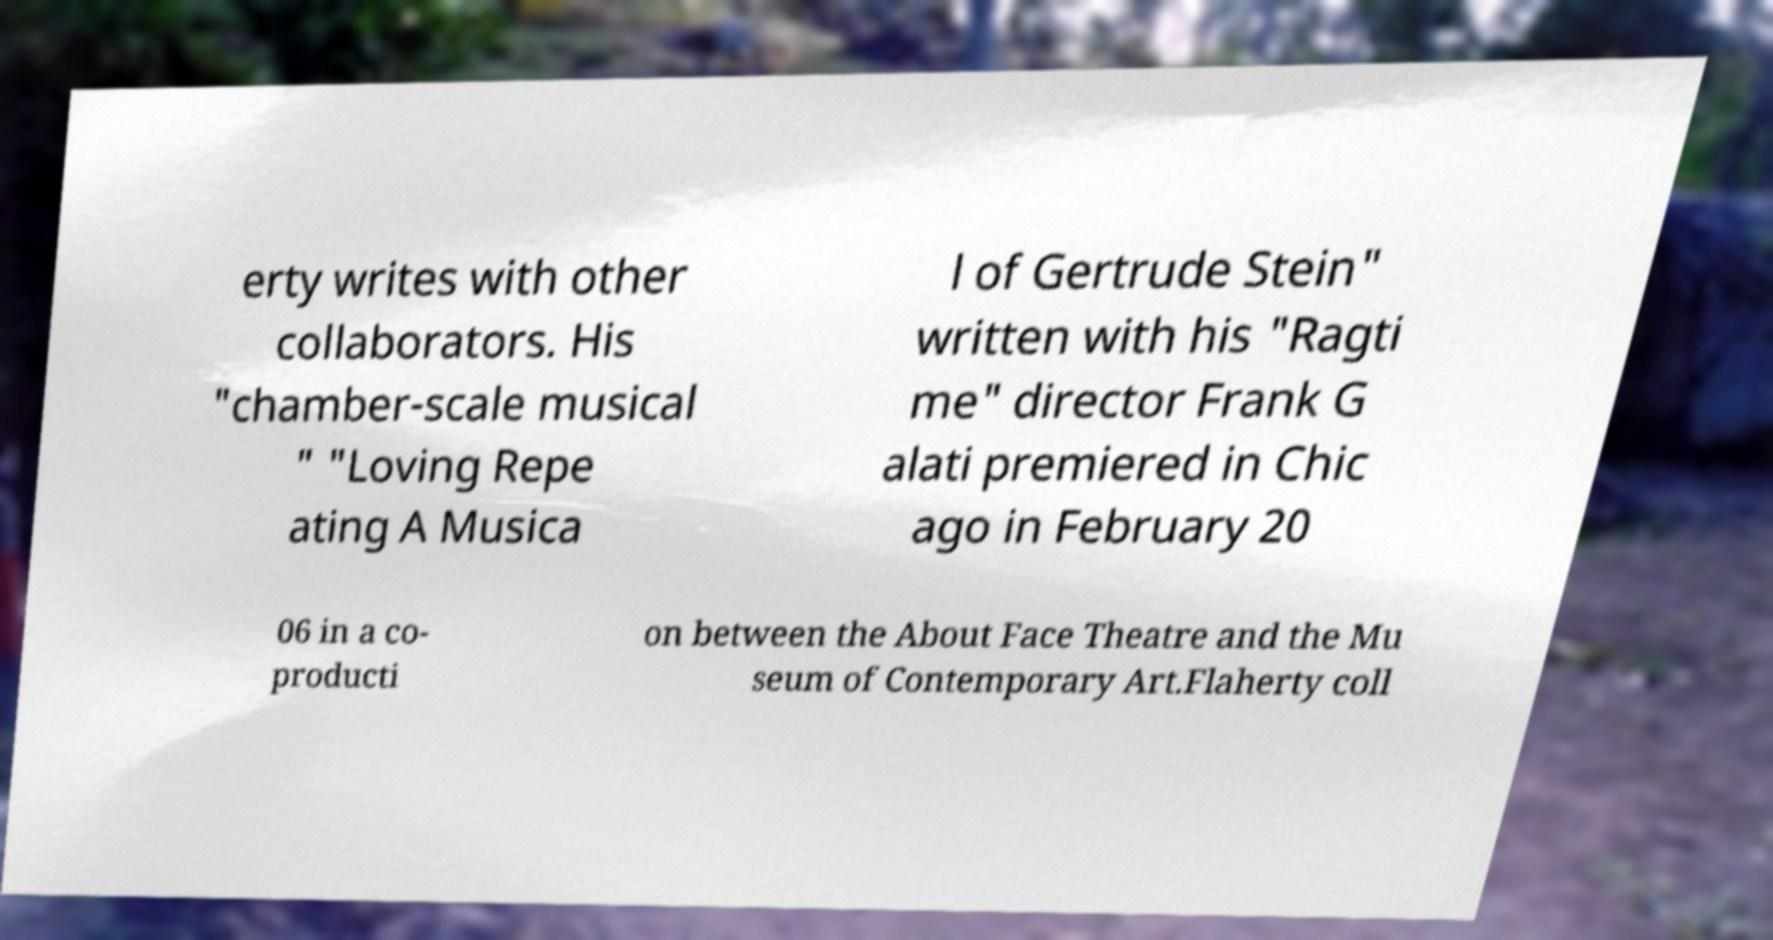Can you read and provide the text displayed in the image?This photo seems to have some interesting text. Can you extract and type it out for me? erty writes with other collaborators. His "chamber-scale musical " "Loving Repe ating A Musica l of Gertrude Stein" written with his "Ragti me" director Frank G alati premiered in Chic ago in February 20 06 in a co- producti on between the About Face Theatre and the Mu seum of Contemporary Art.Flaherty coll 